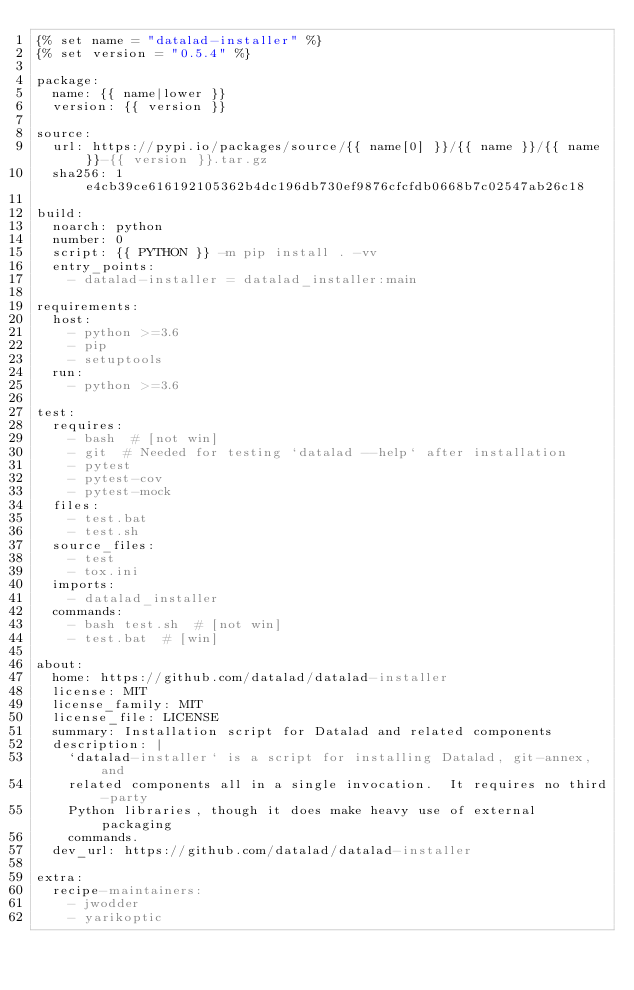Convert code to text. <code><loc_0><loc_0><loc_500><loc_500><_YAML_>{% set name = "datalad-installer" %}
{% set version = "0.5.4" %}

package:
  name: {{ name|lower }}
  version: {{ version }}

source:
  url: https://pypi.io/packages/source/{{ name[0] }}/{{ name }}/{{ name }}-{{ version }}.tar.gz
  sha256: 1e4cb39ce616192105362b4dc196db730ef9876cfcfdb0668b7c02547ab26c18

build:
  noarch: python
  number: 0
  script: {{ PYTHON }} -m pip install . -vv
  entry_points:
    - datalad-installer = datalad_installer:main

requirements:
  host:
    - python >=3.6
    - pip
    - setuptools
  run:
    - python >=3.6

test:
  requires:
    - bash  # [not win]
    - git  # Needed for testing `datalad --help` after installation
    - pytest
    - pytest-cov
    - pytest-mock
  files:
    - test.bat
    - test.sh
  source_files:
    - test
    - tox.ini
  imports:
    - datalad_installer
  commands:
    - bash test.sh  # [not win]
    - test.bat  # [win]

about:
  home: https://github.com/datalad/datalad-installer
  license: MIT
  license_family: MIT
  license_file: LICENSE
  summary: Installation script for Datalad and related components
  description: |
    `datalad-installer` is a script for installing Datalad, git-annex, and
    related components all in a single invocation.  It requires no third-party
    Python libraries, though it does make heavy use of external packaging
    commands.
  dev_url: https://github.com/datalad/datalad-installer

extra:
  recipe-maintainers:
    - jwodder
    - yarikoptic
</code> 